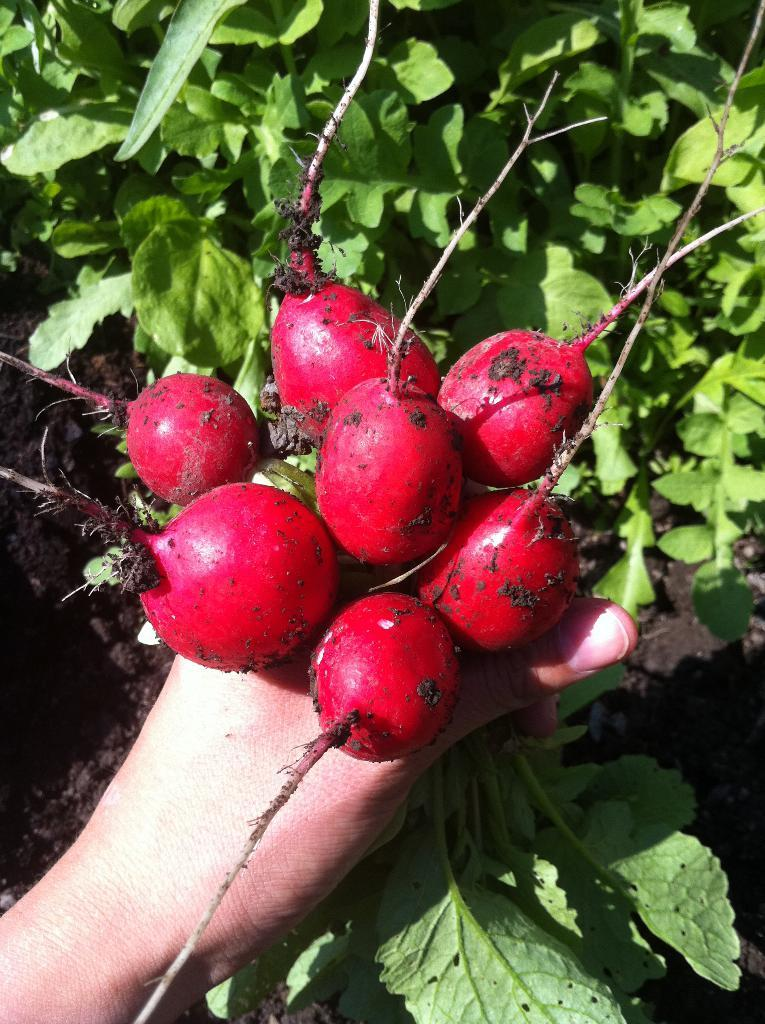What is the person holding in the image? There are beetroots in the person's hand. What can be seen in the background of the image? There are plants in the background of the image. What type of stick is the person using to fulfill their desire in the image? There is no stick or desire mentioned in the image; it only shows a person holding beetroots and plants in the background. 